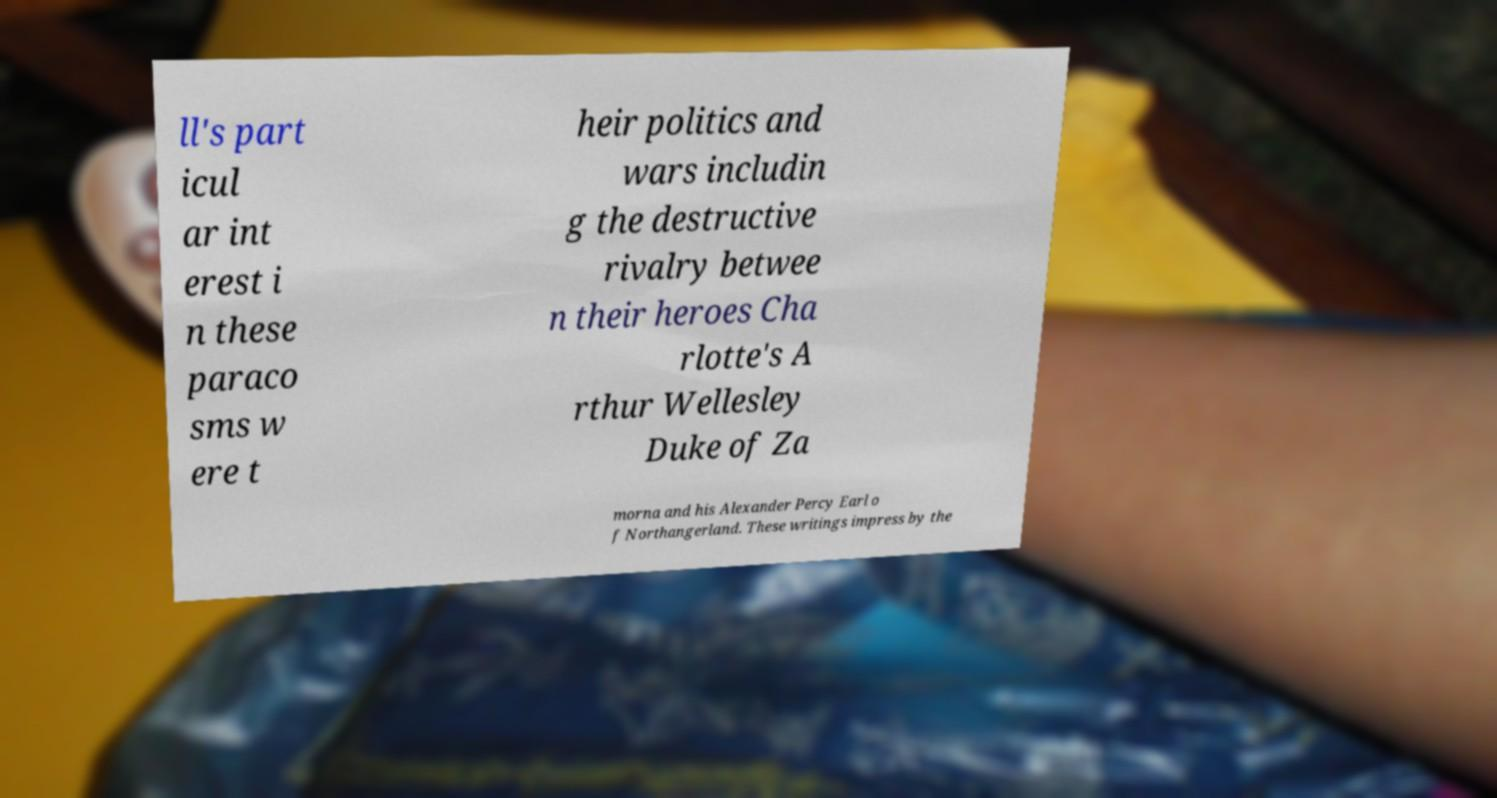Could you extract and type out the text from this image? ll's part icul ar int erest i n these paraco sms w ere t heir politics and wars includin g the destructive rivalry betwee n their heroes Cha rlotte's A rthur Wellesley Duke of Za morna and his Alexander Percy Earl o f Northangerland. These writings impress by the 